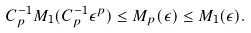<formula> <loc_0><loc_0><loc_500><loc_500>C _ { p } ^ { - 1 } M _ { 1 } ( C _ { p } ^ { - 1 } \epsilon ^ { p } ) \leq M _ { p } ( \epsilon ) \leq M _ { 1 } ( \epsilon ) .</formula> 